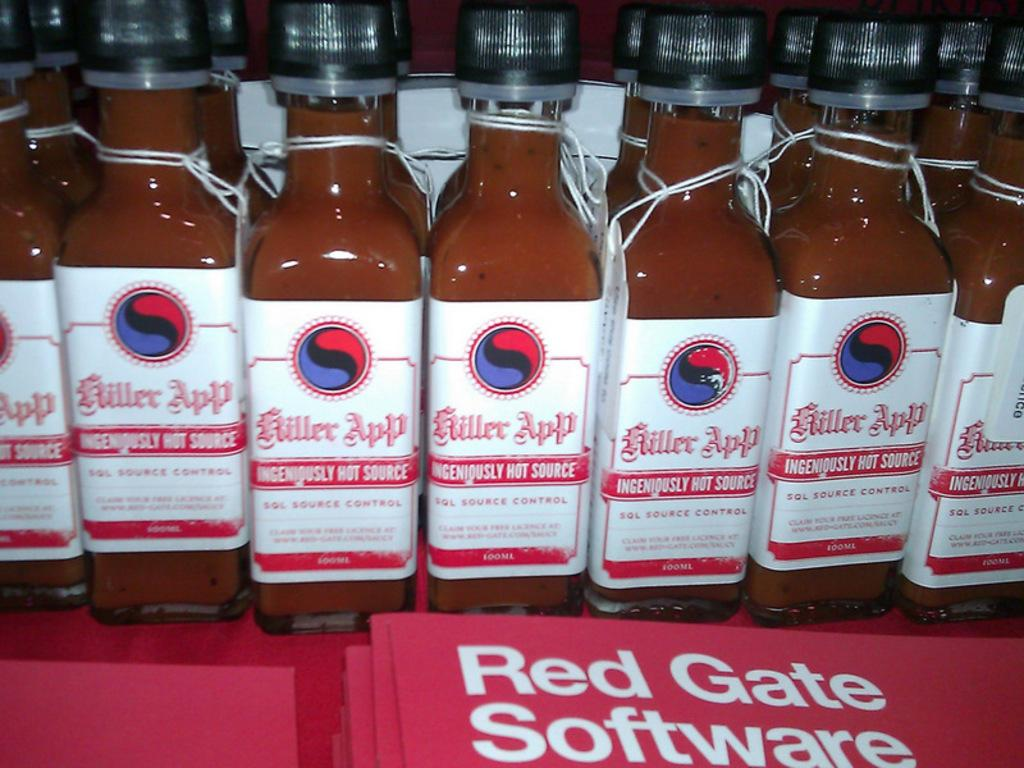<image>
Offer a succinct explanation of the picture presented. Several unopened bottles of Miller App hot sauce sit before red folders with the words Red Gate Software on them. 